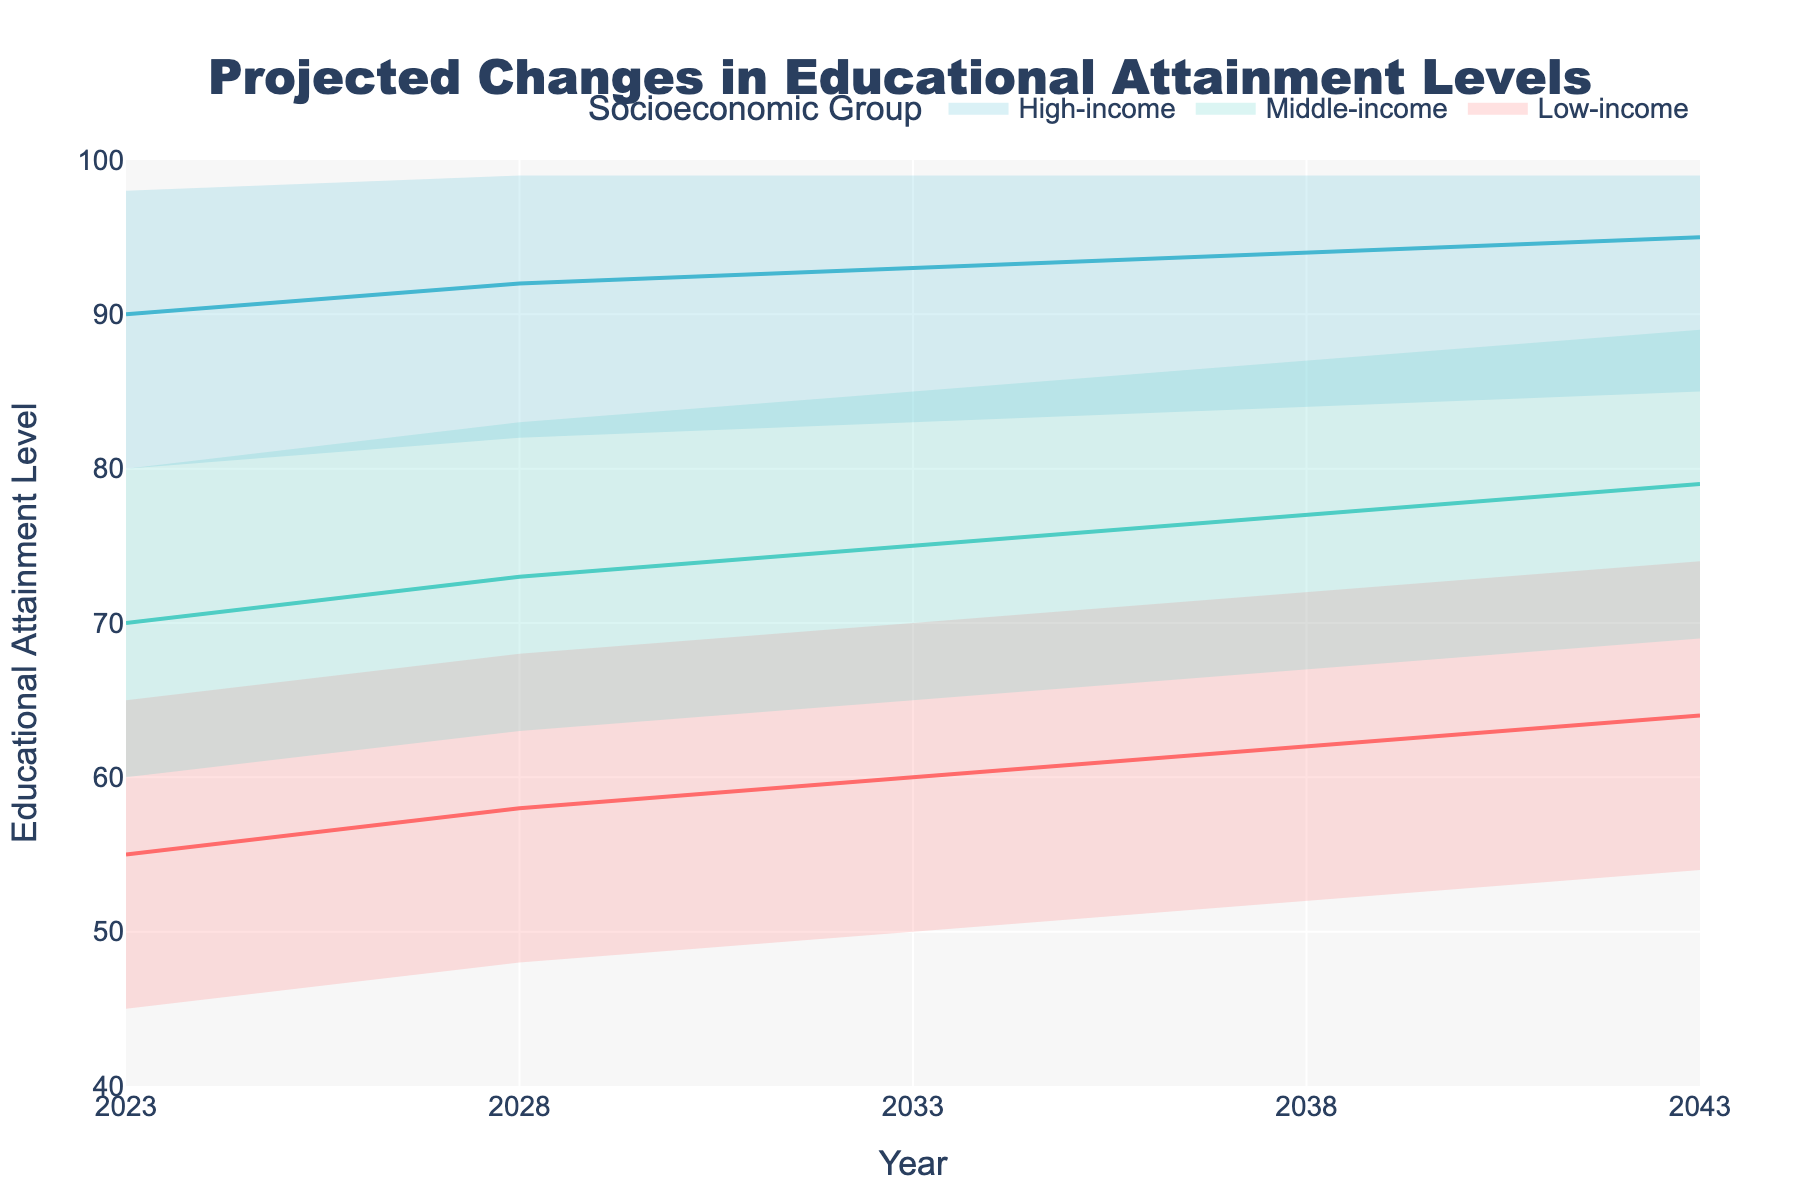What's the title of the chart? The title is usually located at the top of the chart and is meant to describe the main subject of the visual. In this case, it should clearly state the topic of the data being represented.
Answer: Projected Changes in Educational Attainment Levels How many socioeconomic groups are displayed in the chart? By looking at the legend or the distinct areas the shades of color represent, we can count the number of groups.
Answer: Three What is the y-axis label? The y-axis label is typically found along the vertical axis, indicating what is being measured.
Answer: Educational Attainment Level What year shows a median educational attainment level of around 60 for the low-income group? To find this, look for the intersection of the median (central) line for the low-income group with the value 60 on the y-axis.
Answer: 2023 Which group is projected to have the highest educational attainment level by 2043? One way to determine this is to look at the highest point on the y-axis for each group's fan chart in 2043.
Answer: High-income By how much does the median educational attainment level increase from 2023 to 2043 for the middle-income group? First, locate the median values for middle-income in 2023 and 2043, then calculate their difference: 79 - 70.
Answer: 9 Which year shows the smallest difference between the highest and lowest projected attainment levels for high-income groups? Compare the range (difference between highest and lowest values) for high-income across all years.
Answer: 2043 What is the range of educational attainment levels projected for low-income groups in 2033? Find the difference between the highest and lowest projected values for the low-income group in 2033: 70 - 50.
Answer: 20 Which group has the narrowest spread between the low and high projections in 2028? Check each group and compare the range between their highest and lowest values in 2028. The narrowest spread is 14 (99 - 85) for high-income.
Answer: High-income How much does the high projection for educational attainment in low-income groups increase from 2023 to 2043? Subtract the high projection for 2023 from the high projection for 2043 for the low-income group: 74 - 65.
Answer: 9 